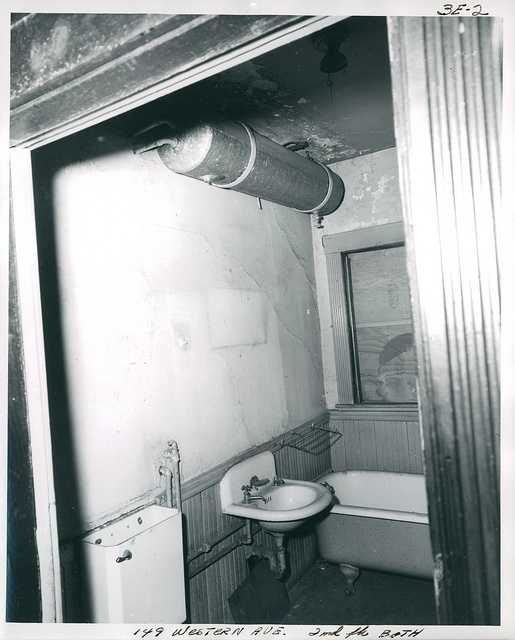Describe the objects in this image and their specific colors. I can see toilet in lightgray, darkgray, black, and gray tones and sink in lightgray, darkgray, and gray tones in this image. 